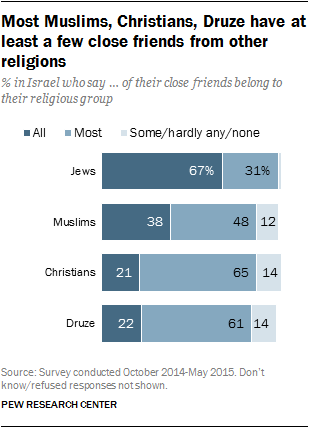Point out several critical features in this image. A recent survey has revealed that a significant number of Christians have no friends of other religions, particularly Muslims. The percentage of Christians who fall into this category is 0.02. The largest dark blue bar is the one that is all the way to the right. 